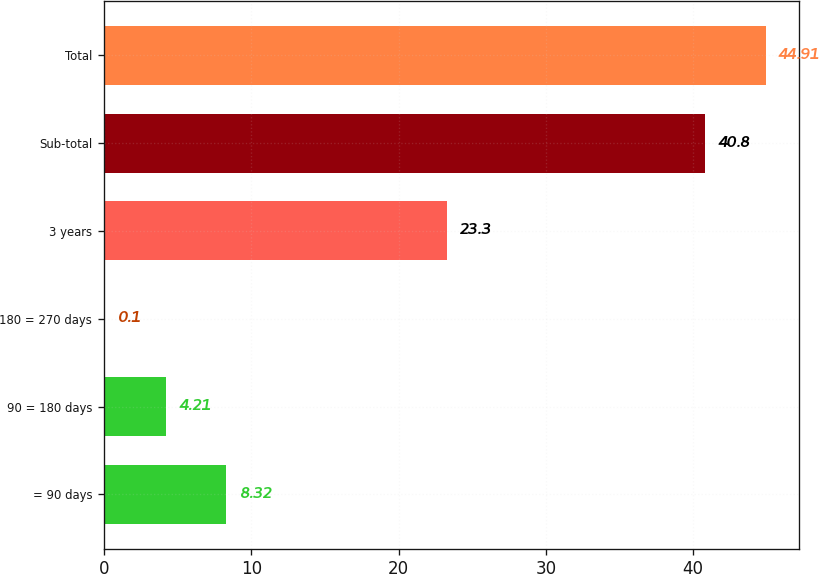Convert chart. <chart><loc_0><loc_0><loc_500><loc_500><bar_chart><fcel>= 90 days<fcel>90 = 180 days<fcel>180 = 270 days<fcel>3 years<fcel>Sub-total<fcel>Total<nl><fcel>8.32<fcel>4.21<fcel>0.1<fcel>23.3<fcel>40.8<fcel>44.91<nl></chart> 